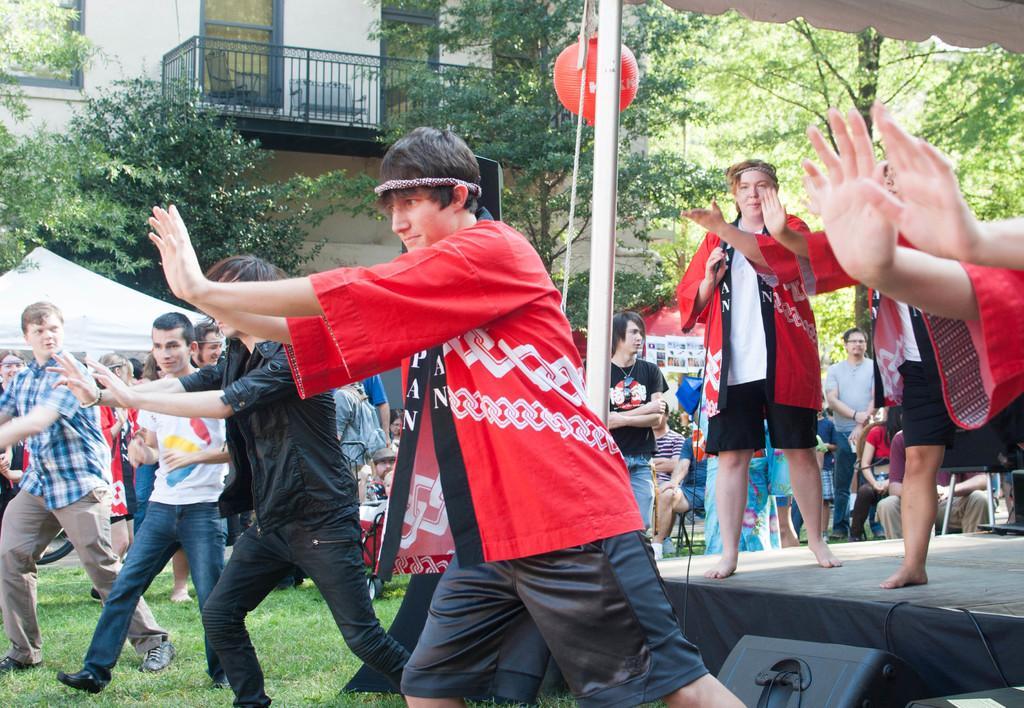In one or two sentences, can you explain what this image depicts? In this image I can see a person wearing red and black colored dress is standing and I can see number of persons are standing on the ground, the stage, few persons standing on the stage, few persons sitting on chairs, few trees which are green in color and a white colored tent. In the background I can see a white colored building, the black colored railing and few windows of the building. 